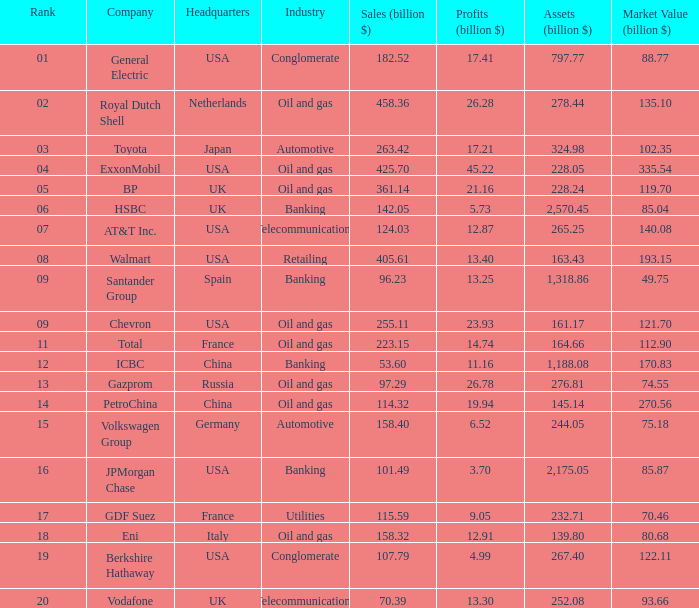How many Assets (billion $) has an Industry of oil and gas, and a Rank of 9, and a Market Value (billion $) larger than 121.7? None. 